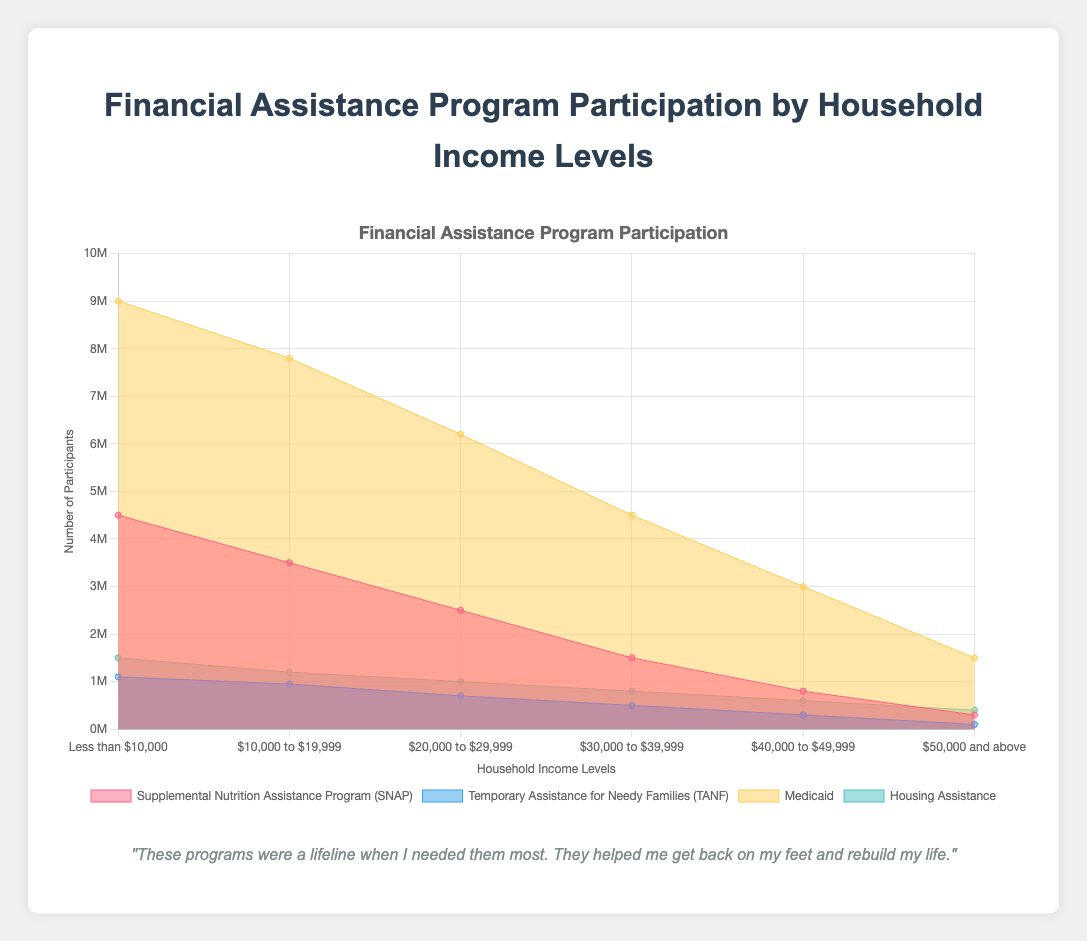What are the four types of financial assistance programs shown in the figure? The figure labels indicate four programs, which are "Supplemental Nutrition Assistance Program (SNAP)", "Temporary Assistance for Needy Families (TANF)", "Medicaid", and "Housing Assistance".
Answer: SNAP, TANF, Medicaid, Housing Assistance Which income level has the highest number of participants in Medicaid? The area representing Medicaid (yellow color) is largest at the leftmost point of the X-axis, labeled 'Less than $10,000', indicating the highest number of participants.
Answer: Less than $10,000 How many participants are in the TANF program at the $20,000 to $29,999 income level? On the X-axis, find the point labeled "$20,000 to $29,999". Move up to the point corresponding to TANF, which is 700,000 participants.
Answer: 700,000 What is the total number of participants in SNAP and Medicaid for households with income less than $10,000? The data points for SNAP and Medicaid at 'Less than $10,000' are 4,500,000 and 9,000,000 respectively. Add these numbers: 4,500,000 + 9,000,000 = 13,500,000 participants.
Answer: 13,500,000 Which financial assistance program has the smallest participation at the $50,000 and above income level? Look at the data points for each program at the "$50,000 and above" income level. TANF has the smallest participation with 100,000 participants.
Answer: TANF Between which two income levels does the participation in Housing Assistance decrease the most? Compare the number of participants in Housing Assistance between consecutive income levels. The decrease is largest between ‘Less than $10,000’ (1,500,000) and ‘$10,000 to $19,999’ (1,200,000), a decrease of 300,000 participants.
Answer: Less than $10,000 and $10,000 to $19,999 By what percentage does participation in SNAP decrease from the 'Less than $10,000' to the '$50,000 and above' income level? Calculate the percentage decrease using the formula: ((initial - final) / initial) * 100. For SNAP: ((4,500,000 - 300,000) / 4,500,000) * 100 = (4,200,000 / 4,500,000) * 100 ≈ 93.33%.
Answer: 93.33% Which program shows the steepest decline in participation as income levels increase from 'Less than $10,000' to '$50,000 and above'? By observing the chart, the steepest decline can be seen in TANF, which drops from 1,100,000 to 100,000 as income increases.
Answer: TANF What is the combined participation in all programs for the income range $40,000 to $49,999? Sum the data points for all programs at '$40,000 to $49,999': 800,000 (SNAP) + 300,000 (TANF) + 3,000,000 (Medicaid) + 600,000 (Housing Assistance) = 4,700,000.
Answer: 4,700,000 